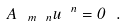Convert formula to latex. <formula><loc_0><loc_0><loc_500><loc_500>A _ { \ m \ n } u ^ { \ n } = 0 \ .</formula> 